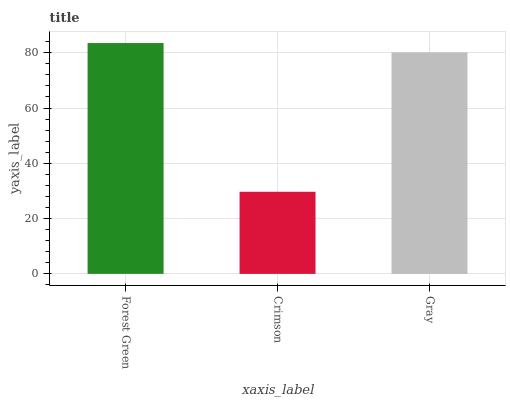Is Crimson the minimum?
Answer yes or no. Yes. Is Forest Green the maximum?
Answer yes or no. Yes. Is Gray the minimum?
Answer yes or no. No. Is Gray the maximum?
Answer yes or no. No. Is Gray greater than Crimson?
Answer yes or no. Yes. Is Crimson less than Gray?
Answer yes or no. Yes. Is Crimson greater than Gray?
Answer yes or no. No. Is Gray less than Crimson?
Answer yes or no. No. Is Gray the high median?
Answer yes or no. Yes. Is Gray the low median?
Answer yes or no. Yes. Is Forest Green the high median?
Answer yes or no. No. Is Forest Green the low median?
Answer yes or no. No. 